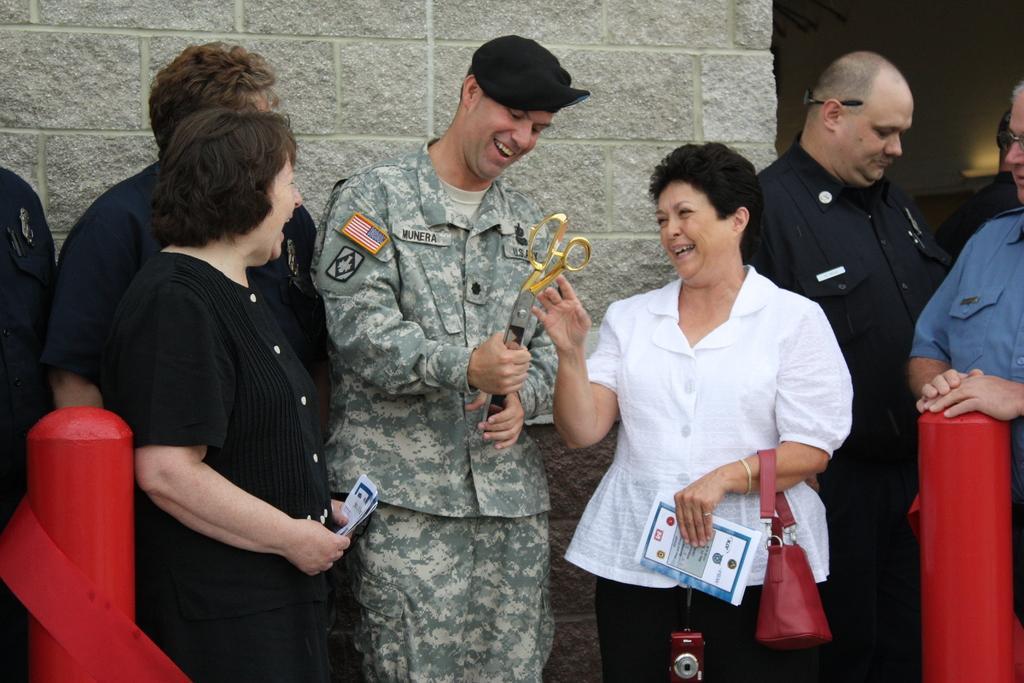Can you describe this image briefly? In the center of the image there are people standing. In the background of the image there is wall. 